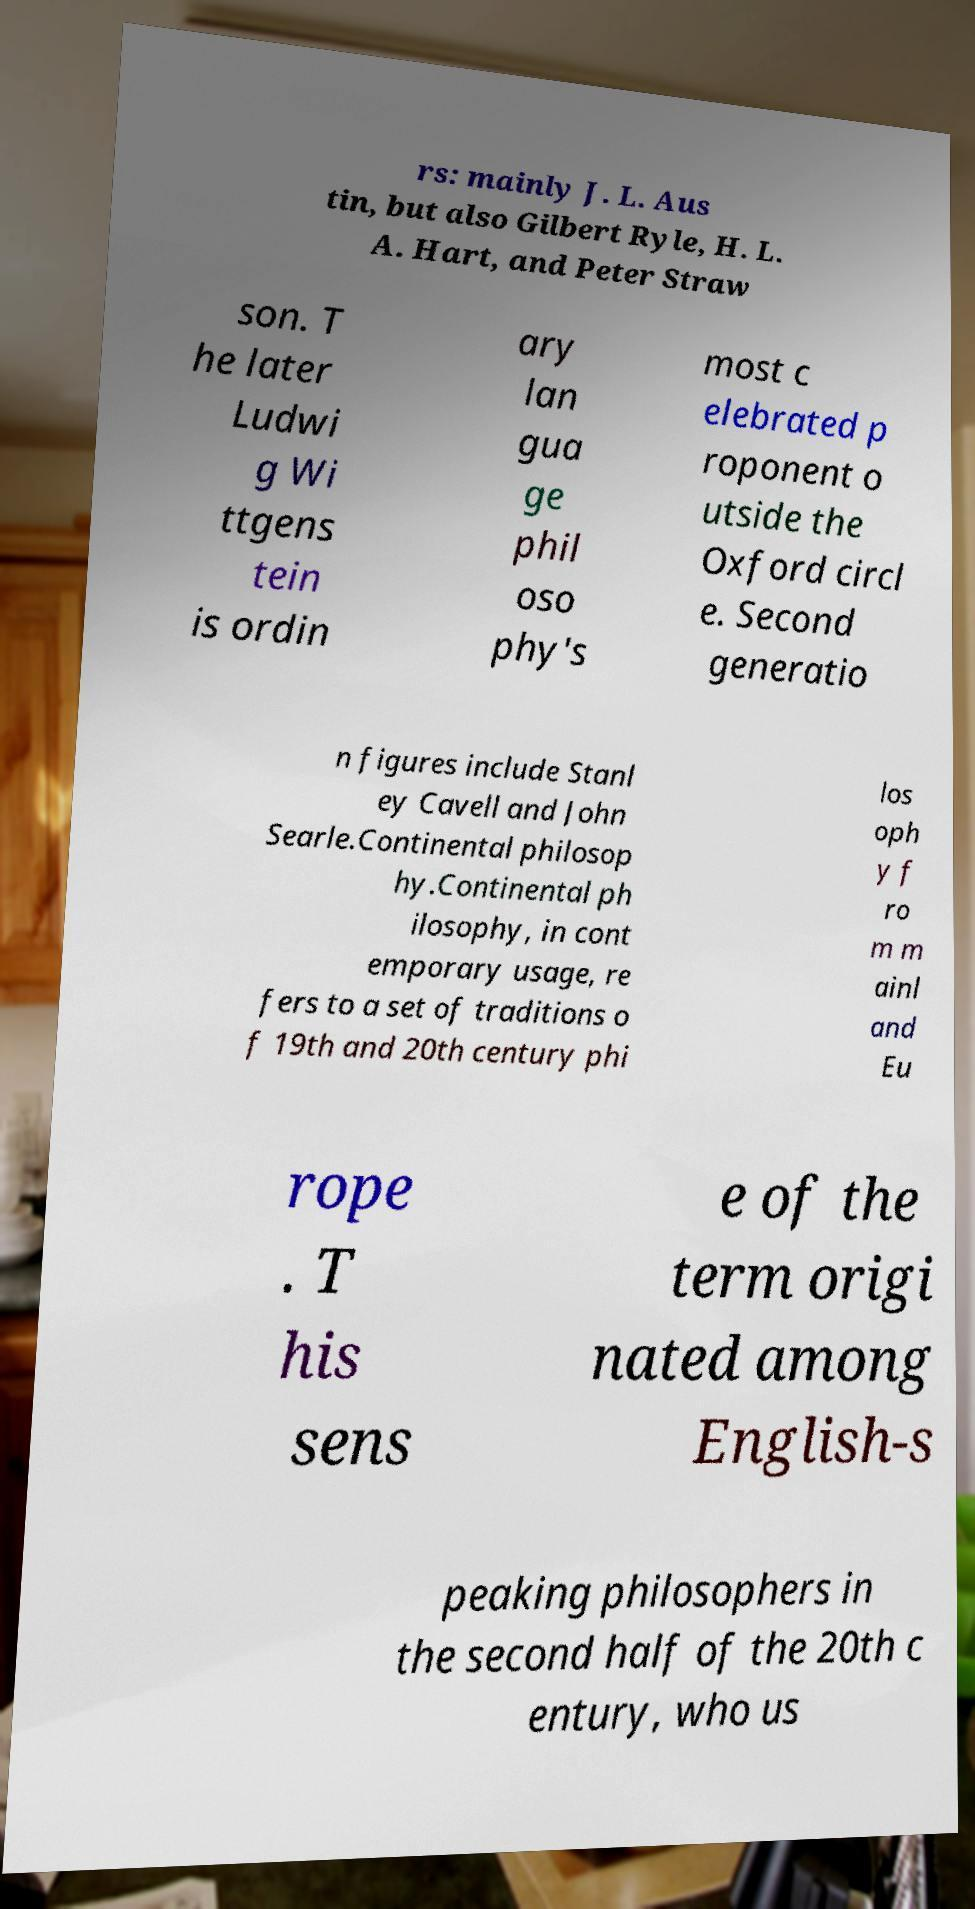Can you accurately transcribe the text from the provided image for me? rs: mainly J. L. Aus tin, but also Gilbert Ryle, H. L. A. Hart, and Peter Straw son. T he later Ludwi g Wi ttgens tein is ordin ary lan gua ge phil oso phy's most c elebrated p roponent o utside the Oxford circl e. Second generatio n figures include Stanl ey Cavell and John Searle.Continental philosop hy.Continental ph ilosophy, in cont emporary usage, re fers to a set of traditions o f 19th and 20th century phi los oph y f ro m m ainl and Eu rope . T his sens e of the term origi nated among English-s peaking philosophers in the second half of the 20th c entury, who us 